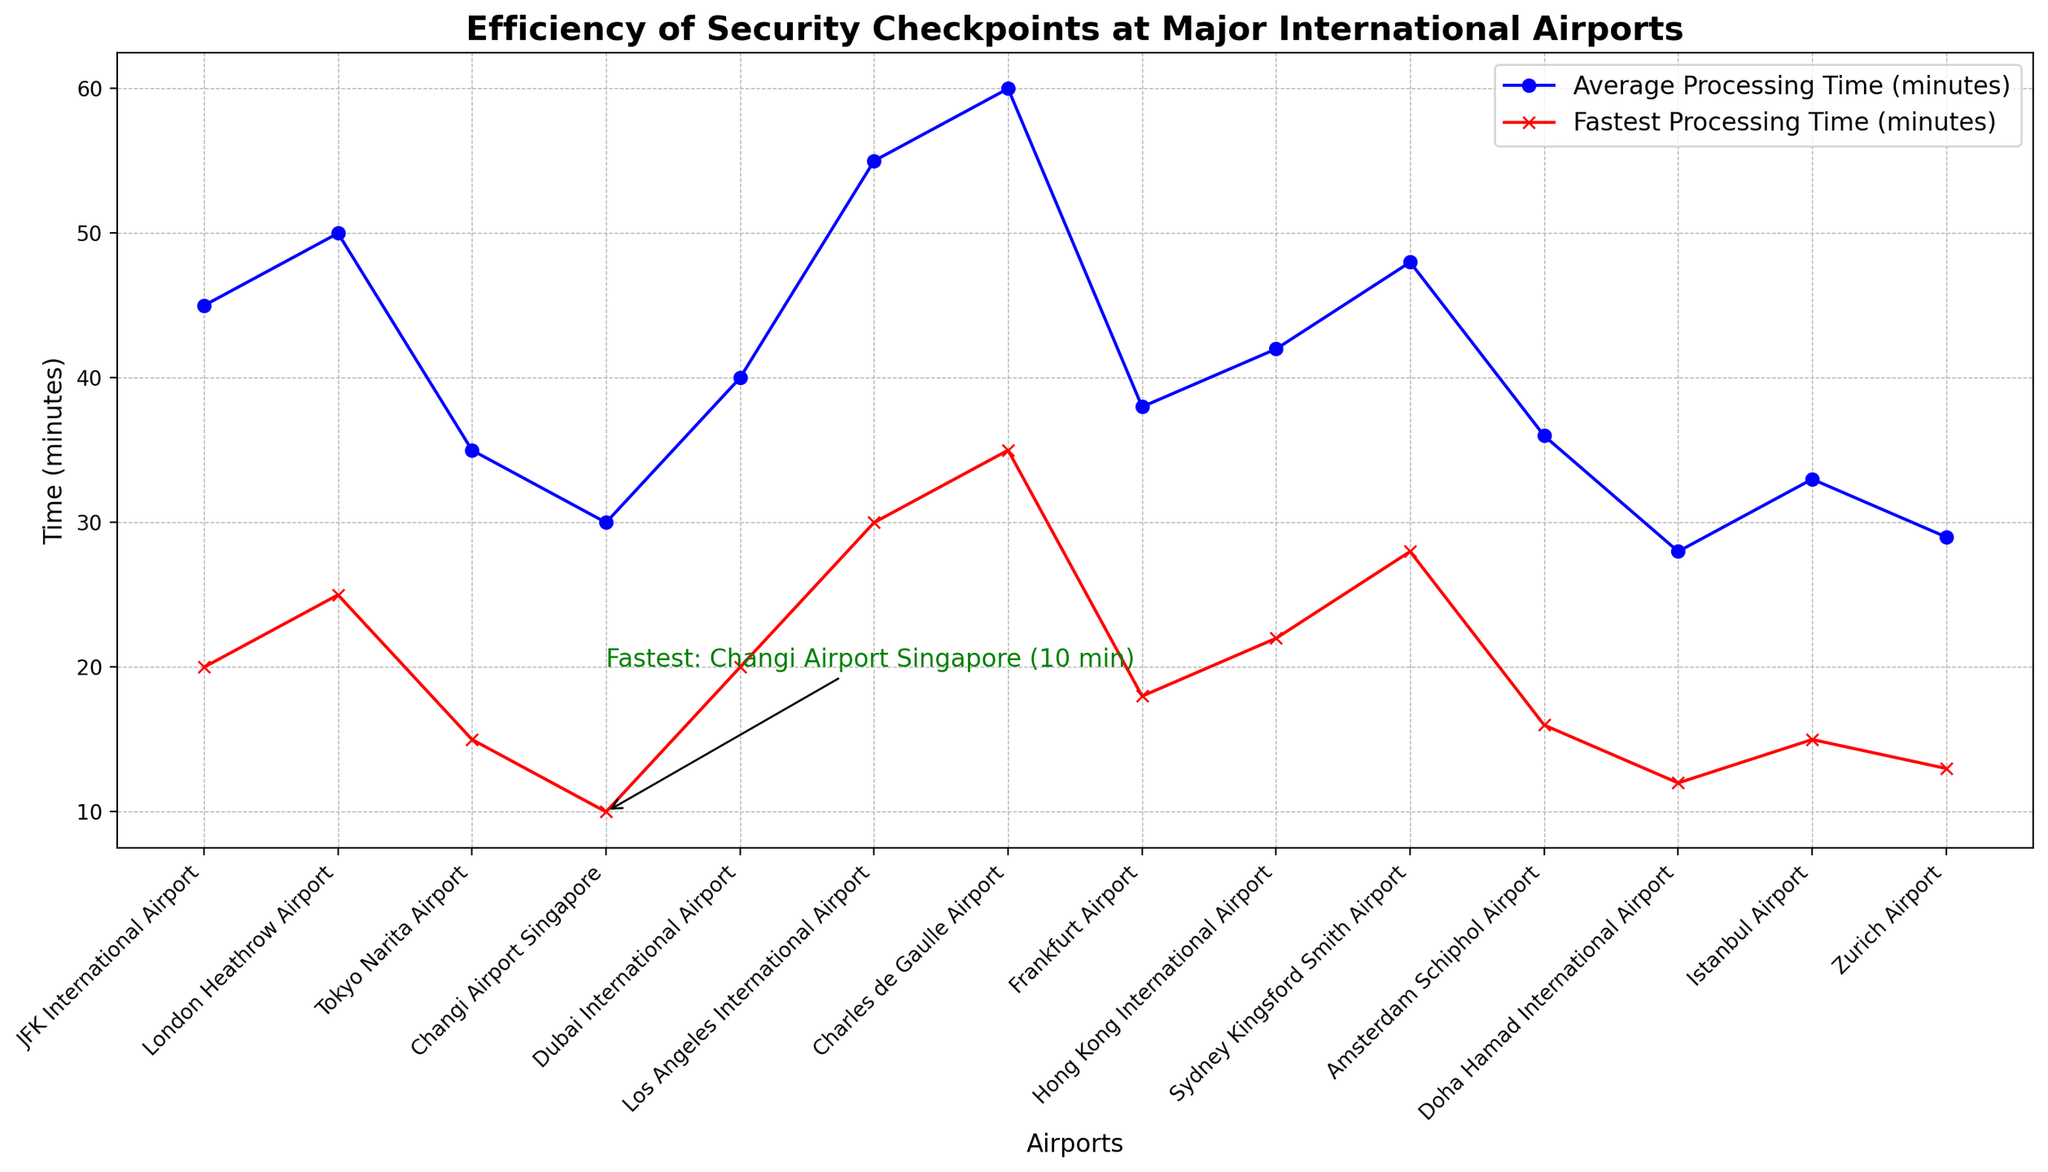What is the relationship between average and fastest processing times at JFK International Airport? The line chart shows two different lines: one for average processing times and one for fastest processing times. For JFK International Airport, observe the positions of the markers on both lines at the JFK label on the x-axis. The average processing time is 45 minutes, and the fastest processing time is 20 minutes.
Answer: JFK average: 45 min, fastest: 20 min Which airport has the fastest processing time, and how is it indicated in the chart? Look for the annotation on the chart. The annotation points to Changi Airport Singapore and states "Fastest: Changi Airport Singapore (10 min)" next to a green arrow. This annotation directly indicates the fastest processing time.
Answer: Changi Airport Singapore Compare the average processing time at Los Angeles International Airport to Zurich Airport. Which one is longer and by how much? Locate the points for Los Angeles International Airport and Zurich Airport on the average processing time (blue line). The average processing time for Los Angeles International Airport is 55 minutes, and for Zurich Airport, it is 29 minutes. Subtract 29 from 55 to find the difference.
Answer: Los Angeles is longer by 26 minutes Which airport has the least difference between its average processing time and fastest processing time? To find the smallest difference, check the distances between the blue and red markers for each airport on the x-axis. Doha Hamad International Airport has an average processing time of 28 minutes and a fastest processing time of 12 minutes, resulting in a difference of 16 minutes.
Answer: Doha Hamad International Airport What is the average processing time for airports with the shortest (Changi Airport Singapore) and longest (Charles de Gaulle Airport) fastest processing times? Refer to Changi Airport Singapore and Charles de Gaulle Airport on the x-axis. The average processing time for Changi Airport Singapore is 30 minutes, and for Charles de Gaulle Airport, it is 60 minutes. Since both airports are specified, no additional calculations are necessary.
Answer: Changi: 30 min, Charles de Gaulle: 60 min Based on the chart, which airport has the highest average processing time and what is this time? Examine the blue line. The marker that is the highest on the y-axis indicates the highest average processing time. This point is at Charles de Gaulle Airport with 60 minutes.
Answer: Charles de Gaulle Airport with 60 min Calculate the difference between the fastest processing times at Tokyo Narita Airport and Frankfurt Airport. Reference the fastest processing times (red line) for Tokyo Narita Airport and Frankfurt Airport. Tokyo Narita has 15 minutes, and Frankfurt has 18 minutes. Subtract 15 from 18 to get the difference.
Answer: 3 minutes What is the overall trend in the efficiency of security checkpoints as visualized in the chart? Generally, the blue (average) and red (fastest) lines indicate that there is a variation across different airports, with some like Changi Airport and Doha Hamad International Airport having notably shorter processing times, while Charles de Gaulle and Los Angeles International Airport have longer times. This suggests variability in efficiency.
Answer: Variability in efficiency across different airports Which airports have an average processing time below 40 minutes? Manhattan's average processing time below the threshold by examining the blue markers on the y-axis. Changi Airport Singapore (30 min), Doha Hamad International Airport (28 min), Zurich Airport (29 min), Tokyo Narita Airport (35 min), and Istanbul Airport (33 min) fall below this mark.
Answer: Changi, Doha Hamad, Zurich, Tokyo Narita, Istanbul 